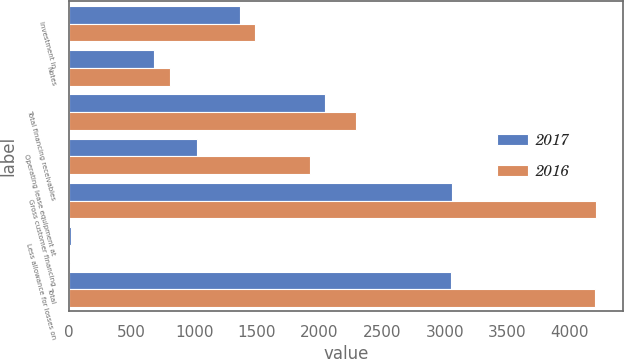Convert chart. <chart><loc_0><loc_0><loc_500><loc_500><stacked_bar_chart><ecel><fcel>Investment in<fcel>Notes<fcel>Total financing receivables<fcel>Operating lease equipment at<fcel>Gross customer financing<fcel>Less allowance for losses on<fcel>Total<nl><fcel>2017<fcel>1364<fcel>677<fcel>2041<fcel>1020<fcel>3061<fcel>12<fcel>3049<nl><fcel>2016<fcel>1482<fcel>807<fcel>2289<fcel>1922<fcel>4211<fcel>10<fcel>4201<nl></chart> 